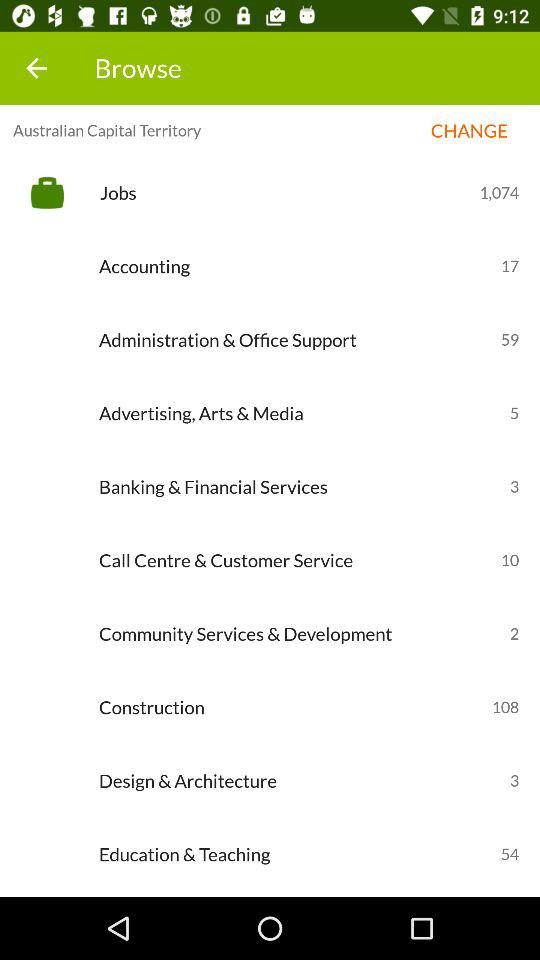Ten jobs are present in what department? There are ten jobs available in call centre & customer service. 